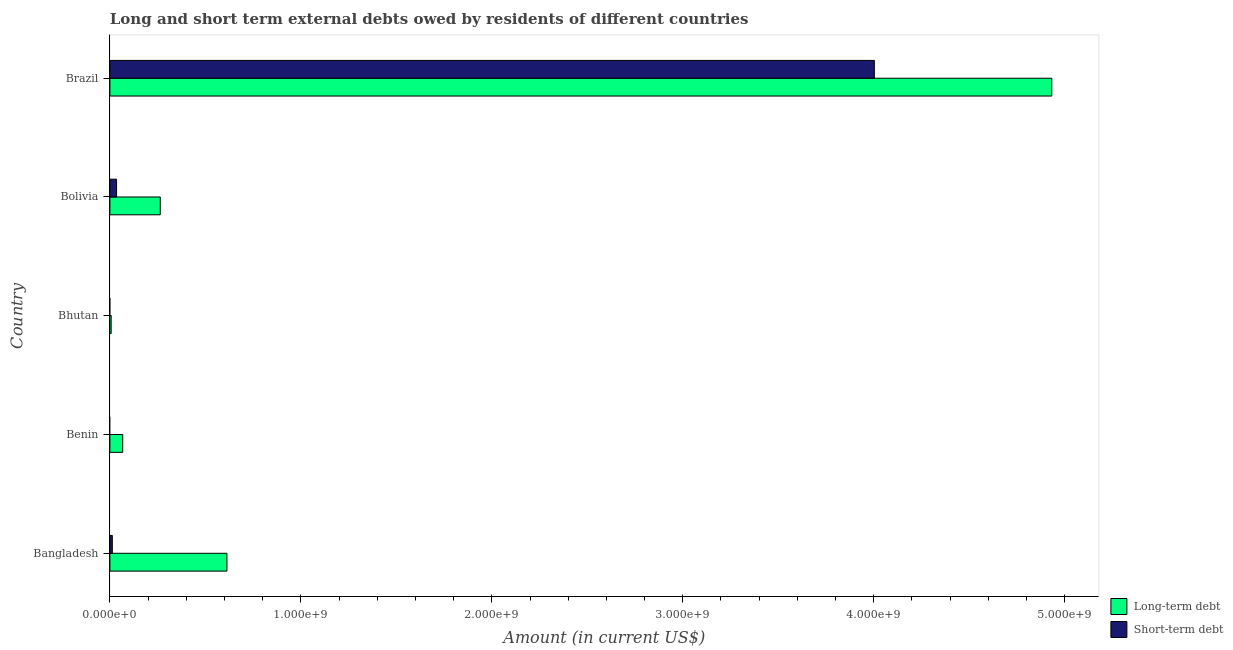How many different coloured bars are there?
Your response must be concise. 2. Are the number of bars per tick equal to the number of legend labels?
Provide a short and direct response. No. Are the number of bars on each tick of the Y-axis equal?
Your response must be concise. No. How many bars are there on the 5th tick from the bottom?
Keep it short and to the point. 2. What is the label of the 2nd group of bars from the top?
Your response must be concise. Bolivia. What is the short-term debts owed by residents in Bangladesh?
Provide a succinct answer. 1.28e+07. Across all countries, what is the maximum short-term debts owed by residents?
Your answer should be very brief. 4.00e+09. In which country was the long-term debts owed by residents maximum?
Your response must be concise. Brazil. What is the total long-term debts owed by residents in the graph?
Your answer should be compact. 5.88e+09. What is the difference between the long-term debts owed by residents in Bangladesh and that in Brazil?
Ensure brevity in your answer.  -4.32e+09. What is the difference between the long-term debts owed by residents in Brazil and the short-term debts owed by residents in Bolivia?
Provide a short and direct response. 4.90e+09. What is the average short-term debts owed by residents per country?
Ensure brevity in your answer.  8.10e+08. What is the difference between the short-term debts owed by residents and long-term debts owed by residents in Bangladesh?
Provide a succinct answer. -6.00e+08. In how many countries, is the short-term debts owed by residents greater than 800000000 US$?
Offer a terse response. 1. What is the ratio of the long-term debts owed by residents in Bolivia to that in Brazil?
Give a very brief answer. 0.05. Is the long-term debts owed by residents in Benin less than that in Bolivia?
Offer a very short reply. Yes. What is the difference between the highest and the second highest short-term debts owed by residents?
Ensure brevity in your answer.  3.97e+09. What is the difference between the highest and the lowest long-term debts owed by residents?
Your answer should be compact. 4.93e+09. In how many countries, is the long-term debts owed by residents greater than the average long-term debts owed by residents taken over all countries?
Give a very brief answer. 1. Is the sum of the long-term debts owed by residents in Benin and Bhutan greater than the maximum short-term debts owed by residents across all countries?
Offer a terse response. No. How many bars are there?
Your response must be concise. 8. Are all the bars in the graph horizontal?
Make the answer very short. Yes. What is the difference between two consecutive major ticks on the X-axis?
Provide a succinct answer. 1.00e+09. Does the graph contain any zero values?
Keep it short and to the point. Yes. What is the title of the graph?
Give a very brief answer. Long and short term external debts owed by residents of different countries. Does "Overweight" appear as one of the legend labels in the graph?
Your response must be concise. No. What is the label or title of the X-axis?
Offer a very short reply. Amount (in current US$). What is the label or title of the Y-axis?
Provide a short and direct response. Country. What is the Amount (in current US$) in Long-term debt in Bangladesh?
Ensure brevity in your answer.  6.13e+08. What is the Amount (in current US$) in Short-term debt in Bangladesh?
Offer a terse response. 1.28e+07. What is the Amount (in current US$) of Long-term debt in Benin?
Offer a very short reply. 6.72e+07. What is the Amount (in current US$) of Long-term debt in Bhutan?
Provide a succinct answer. 6.62e+06. What is the Amount (in current US$) of Short-term debt in Bhutan?
Your answer should be very brief. 0. What is the Amount (in current US$) in Long-term debt in Bolivia?
Offer a very short reply. 2.64e+08. What is the Amount (in current US$) of Short-term debt in Bolivia?
Your answer should be very brief. 3.50e+07. What is the Amount (in current US$) in Long-term debt in Brazil?
Give a very brief answer. 4.93e+09. What is the Amount (in current US$) in Short-term debt in Brazil?
Give a very brief answer. 4.00e+09. Across all countries, what is the maximum Amount (in current US$) of Long-term debt?
Your response must be concise. 4.93e+09. Across all countries, what is the maximum Amount (in current US$) in Short-term debt?
Provide a succinct answer. 4.00e+09. Across all countries, what is the minimum Amount (in current US$) in Long-term debt?
Offer a very short reply. 6.62e+06. What is the total Amount (in current US$) in Long-term debt in the graph?
Provide a short and direct response. 5.88e+09. What is the total Amount (in current US$) in Short-term debt in the graph?
Provide a short and direct response. 4.05e+09. What is the difference between the Amount (in current US$) of Long-term debt in Bangladesh and that in Benin?
Provide a short and direct response. 5.46e+08. What is the difference between the Amount (in current US$) of Long-term debt in Bangladesh and that in Bhutan?
Make the answer very short. 6.06e+08. What is the difference between the Amount (in current US$) in Long-term debt in Bangladesh and that in Bolivia?
Give a very brief answer. 3.49e+08. What is the difference between the Amount (in current US$) of Short-term debt in Bangladesh and that in Bolivia?
Make the answer very short. -2.22e+07. What is the difference between the Amount (in current US$) in Long-term debt in Bangladesh and that in Brazil?
Provide a succinct answer. -4.32e+09. What is the difference between the Amount (in current US$) in Short-term debt in Bangladesh and that in Brazil?
Keep it short and to the point. -3.99e+09. What is the difference between the Amount (in current US$) in Long-term debt in Benin and that in Bhutan?
Offer a terse response. 6.05e+07. What is the difference between the Amount (in current US$) of Long-term debt in Benin and that in Bolivia?
Ensure brevity in your answer.  -1.97e+08. What is the difference between the Amount (in current US$) of Long-term debt in Benin and that in Brazil?
Your answer should be very brief. -4.87e+09. What is the difference between the Amount (in current US$) in Long-term debt in Bhutan and that in Bolivia?
Your response must be concise. -2.57e+08. What is the difference between the Amount (in current US$) in Long-term debt in Bhutan and that in Brazil?
Offer a terse response. -4.93e+09. What is the difference between the Amount (in current US$) in Long-term debt in Bolivia and that in Brazil?
Your answer should be very brief. -4.67e+09. What is the difference between the Amount (in current US$) of Short-term debt in Bolivia and that in Brazil?
Give a very brief answer. -3.97e+09. What is the difference between the Amount (in current US$) in Long-term debt in Bangladesh and the Amount (in current US$) in Short-term debt in Bolivia?
Your answer should be compact. 5.78e+08. What is the difference between the Amount (in current US$) of Long-term debt in Bangladesh and the Amount (in current US$) of Short-term debt in Brazil?
Offer a terse response. -3.39e+09. What is the difference between the Amount (in current US$) of Long-term debt in Benin and the Amount (in current US$) of Short-term debt in Bolivia?
Give a very brief answer. 3.21e+07. What is the difference between the Amount (in current US$) in Long-term debt in Benin and the Amount (in current US$) in Short-term debt in Brazil?
Ensure brevity in your answer.  -3.94e+09. What is the difference between the Amount (in current US$) in Long-term debt in Bhutan and the Amount (in current US$) in Short-term debt in Bolivia?
Offer a terse response. -2.84e+07. What is the difference between the Amount (in current US$) in Long-term debt in Bhutan and the Amount (in current US$) in Short-term debt in Brazil?
Give a very brief answer. -4.00e+09. What is the difference between the Amount (in current US$) in Long-term debt in Bolivia and the Amount (in current US$) in Short-term debt in Brazil?
Give a very brief answer. -3.74e+09. What is the average Amount (in current US$) in Long-term debt per country?
Provide a succinct answer. 1.18e+09. What is the average Amount (in current US$) in Short-term debt per country?
Provide a short and direct response. 8.10e+08. What is the difference between the Amount (in current US$) of Long-term debt and Amount (in current US$) of Short-term debt in Bangladesh?
Give a very brief answer. 6.00e+08. What is the difference between the Amount (in current US$) of Long-term debt and Amount (in current US$) of Short-term debt in Bolivia?
Your answer should be compact. 2.29e+08. What is the difference between the Amount (in current US$) of Long-term debt and Amount (in current US$) of Short-term debt in Brazil?
Provide a short and direct response. 9.29e+08. What is the ratio of the Amount (in current US$) of Long-term debt in Bangladesh to that in Benin?
Your response must be concise. 9.13. What is the ratio of the Amount (in current US$) of Long-term debt in Bangladesh to that in Bhutan?
Provide a short and direct response. 92.61. What is the ratio of the Amount (in current US$) in Long-term debt in Bangladesh to that in Bolivia?
Ensure brevity in your answer.  2.32. What is the ratio of the Amount (in current US$) of Short-term debt in Bangladesh to that in Bolivia?
Give a very brief answer. 0.37. What is the ratio of the Amount (in current US$) of Long-term debt in Bangladesh to that in Brazil?
Offer a very short reply. 0.12. What is the ratio of the Amount (in current US$) of Short-term debt in Bangladesh to that in Brazil?
Give a very brief answer. 0. What is the ratio of the Amount (in current US$) of Long-term debt in Benin to that in Bhutan?
Ensure brevity in your answer.  10.15. What is the ratio of the Amount (in current US$) in Long-term debt in Benin to that in Bolivia?
Ensure brevity in your answer.  0.25. What is the ratio of the Amount (in current US$) in Long-term debt in Benin to that in Brazil?
Provide a short and direct response. 0.01. What is the ratio of the Amount (in current US$) of Long-term debt in Bhutan to that in Bolivia?
Provide a succinct answer. 0.03. What is the ratio of the Amount (in current US$) in Long-term debt in Bhutan to that in Brazil?
Your answer should be very brief. 0. What is the ratio of the Amount (in current US$) of Long-term debt in Bolivia to that in Brazil?
Give a very brief answer. 0.05. What is the ratio of the Amount (in current US$) in Short-term debt in Bolivia to that in Brazil?
Provide a short and direct response. 0.01. What is the difference between the highest and the second highest Amount (in current US$) of Long-term debt?
Give a very brief answer. 4.32e+09. What is the difference between the highest and the second highest Amount (in current US$) of Short-term debt?
Provide a short and direct response. 3.97e+09. What is the difference between the highest and the lowest Amount (in current US$) of Long-term debt?
Offer a terse response. 4.93e+09. What is the difference between the highest and the lowest Amount (in current US$) of Short-term debt?
Provide a succinct answer. 4.00e+09. 